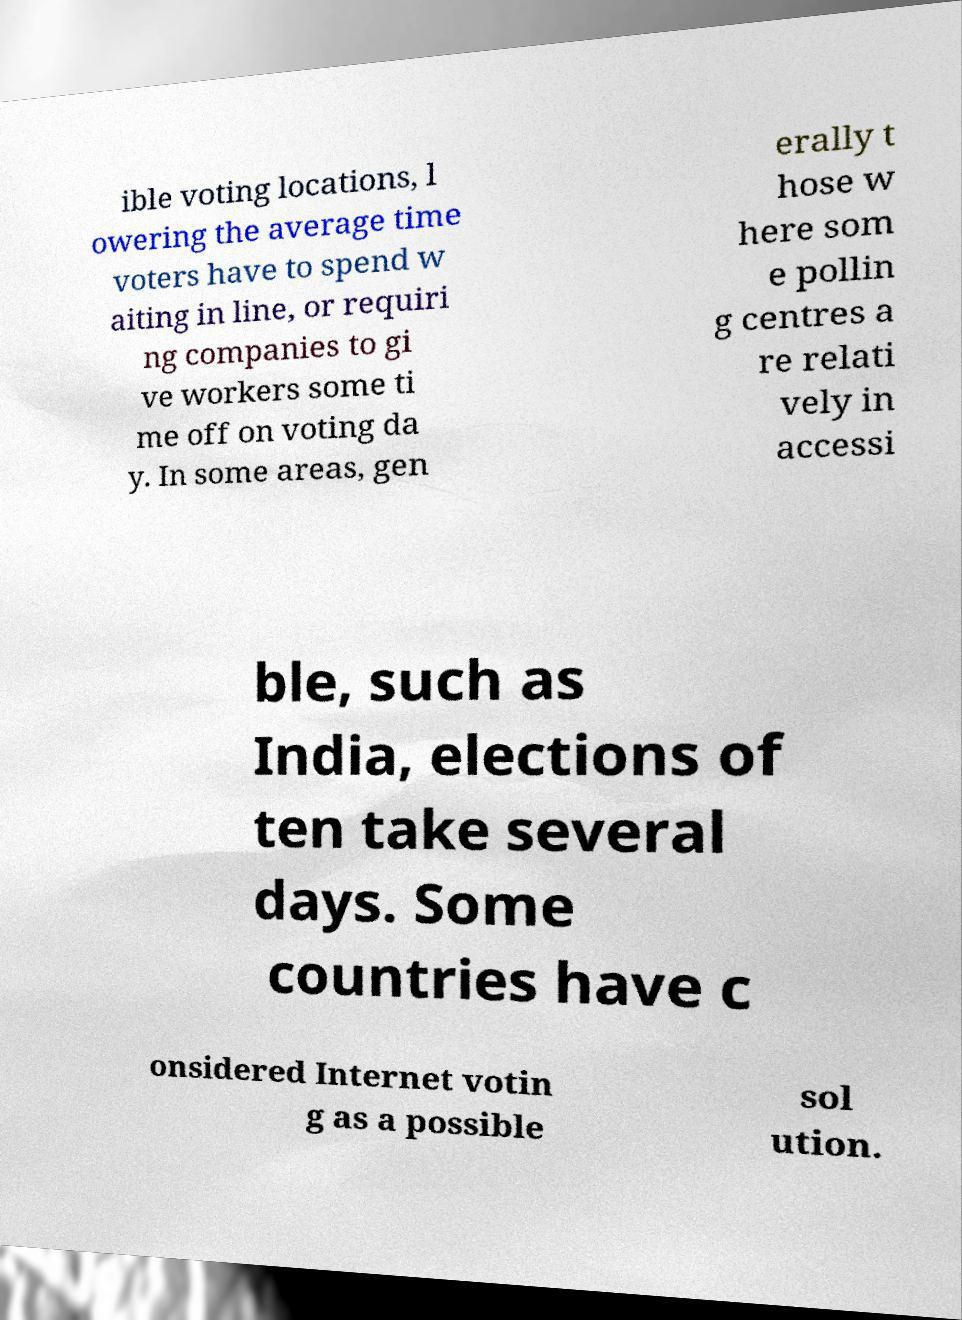Please identify and transcribe the text found in this image. ible voting locations, l owering the average time voters have to spend w aiting in line, or requiri ng companies to gi ve workers some ti me off on voting da y. In some areas, gen erally t hose w here som e pollin g centres a re relati vely in accessi ble, such as India, elections of ten take several days. Some countries have c onsidered Internet votin g as a possible sol ution. 